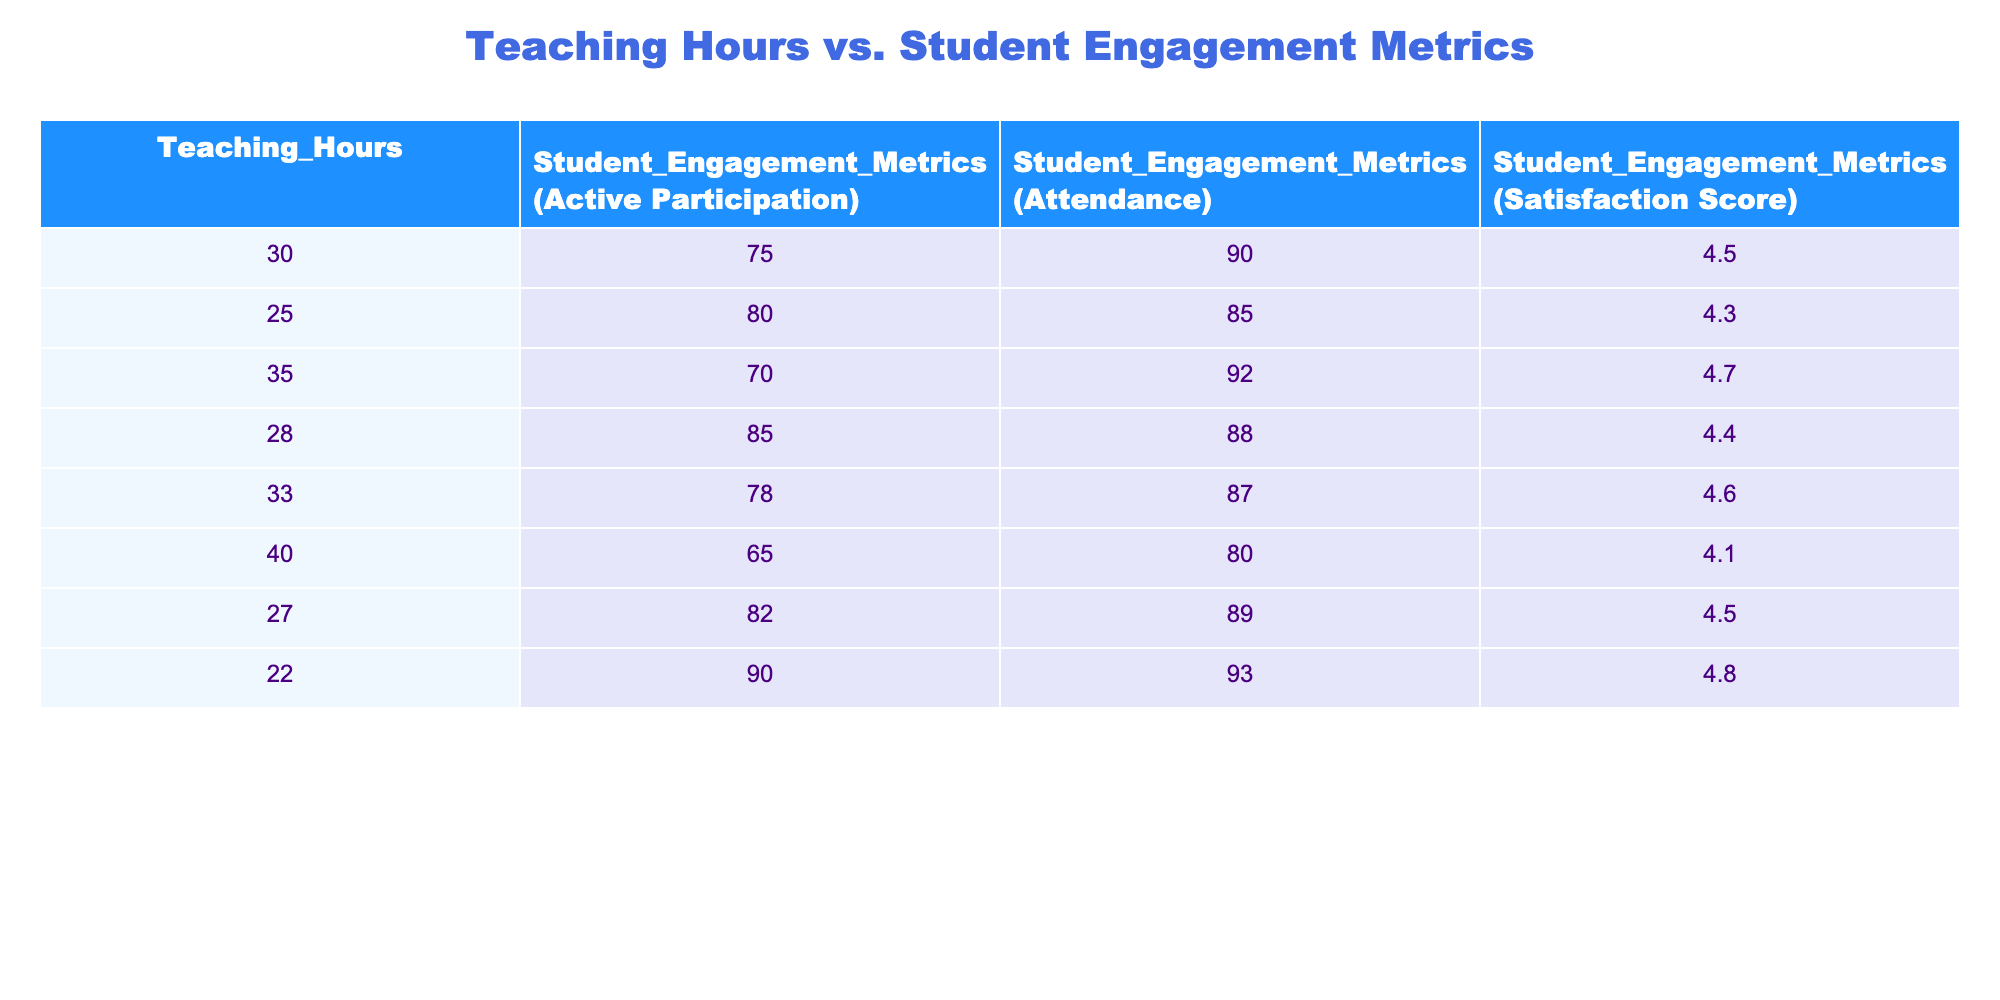What is the highest student satisfaction score recorded? The table lists student satisfaction scores, and the highest value among them is 4.8, found in the row with 22 teaching hours.
Answer: 4.8 What are the teaching hours corresponding to an active participation metric of 85? Looking through the table, the active participation metric of 85 is associated with 28 teaching hours.
Answer: 28 What is the average attendance metric across all teaching hours? Summing the attendance values (90 + 85 + 92 + 88 + 87 + 80 + 89 + 93) gives 704. There are 8 entries, so the average is 704/8 = 88.
Answer: 88 Is there a direct correlation between teaching hours and student satisfaction score based on this data? The scores vary without a clear, consistent trend relative to teaching hours, indicating that a direct correlation may not exist within this dataset.
Answer: No What is the difference in active participation metrics between the highest and lowest teaching hours? The highest teaching hours are 40 (with active participation of 65), and the lowest are 22 (with active participation of 90). The difference is 90 - 65 = 25.
Answer: 25 How many teaching hours correspond to a student engagement metric of 70? The active participation metric of 70 correlates with 35 teaching hours, as presented in the table.
Answer: 35 Which row contains the highest student engagement metrics for active participation and how many teaching hours are associated with it? The maximum active participation is 90, found in the row where teaching hours are 22.
Answer: 22 What is the median satisfaction score from the table? To find the median, we list the satisfaction scores in order: 4.1, 4.3, 4.4, 4.5, 4.5, 4.6, 4.7, 4.8. The median (average of the two central scores) is (4.5 + 4.5)/2 = 4.5.
Answer: 4.5 Which teaching hours have lower than average attendance metrics and what is the average attendance? The average attendance is 88 (calculated as previously outlined). The rows with lower attendance are 40 hours (80), 35 hours (92), and 30 hours (90).
Answer: 80 (40 hours) and 90 (30 hours) What is the total student engagement for attendance metrics that are above 88? The attendance metrics above 88 are 90 (30 hours), 92 (35 hours), and 89 (27 hours). Thus, the total is 90 + 92 + 89 = 271.
Answer: 271 